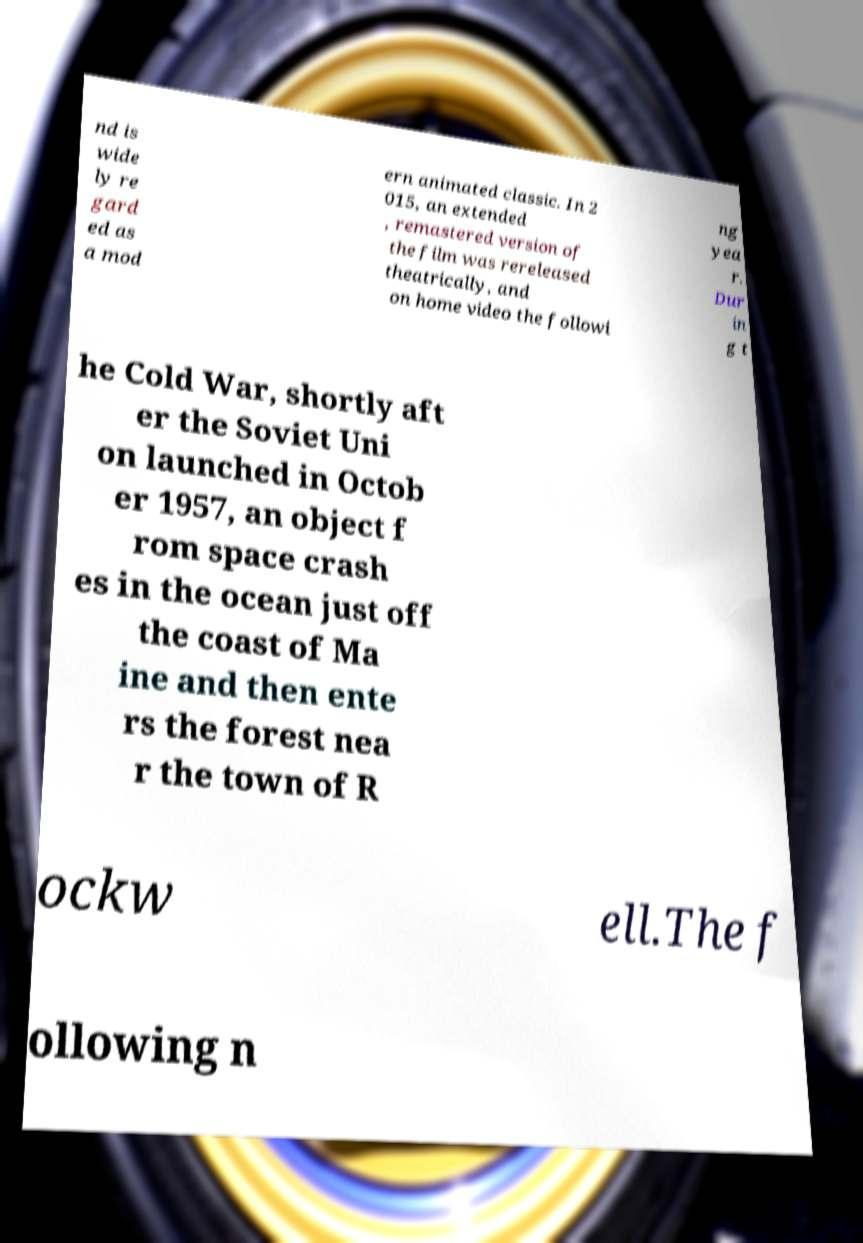Please identify and transcribe the text found in this image. nd is wide ly re gard ed as a mod ern animated classic. In 2 015, an extended , remastered version of the film was rereleased theatrically, and on home video the followi ng yea r. Dur in g t he Cold War, shortly aft er the Soviet Uni on launched in Octob er 1957, an object f rom space crash es in the ocean just off the coast of Ma ine and then ente rs the forest nea r the town of R ockw ell.The f ollowing n 